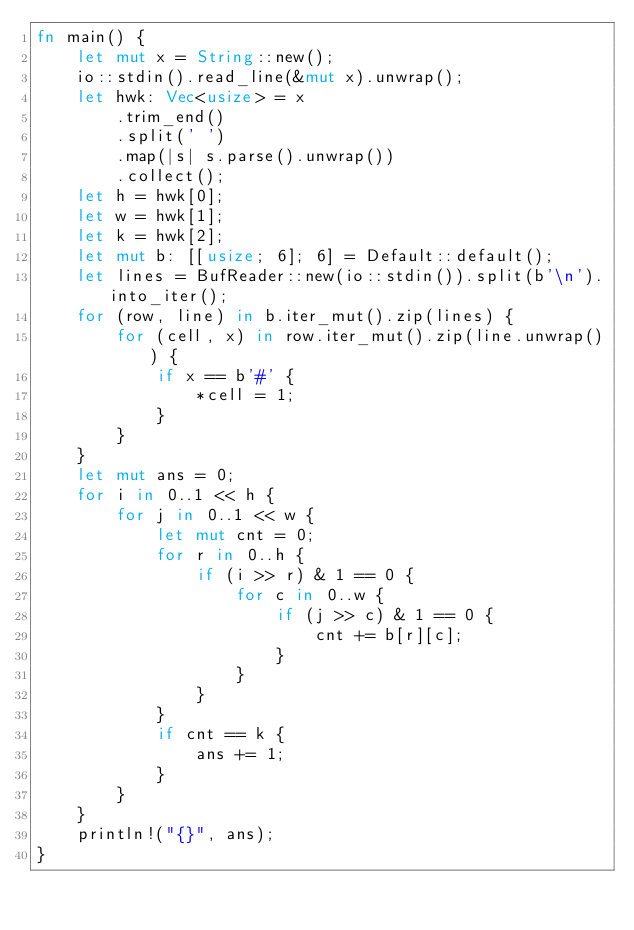<code> <loc_0><loc_0><loc_500><loc_500><_Rust_>fn main() {
    let mut x = String::new();
    io::stdin().read_line(&mut x).unwrap();
    let hwk: Vec<usize> = x
        .trim_end()
        .split(' ')
        .map(|s| s.parse().unwrap())
        .collect();
    let h = hwk[0];
    let w = hwk[1];
    let k = hwk[2];
    let mut b: [[usize; 6]; 6] = Default::default();
    let lines = BufReader::new(io::stdin()).split(b'\n').into_iter();
    for (row, line) in b.iter_mut().zip(lines) {
        for (cell, x) in row.iter_mut().zip(line.unwrap()) {
            if x == b'#' {
                *cell = 1;
            }
        }
    }
    let mut ans = 0;
    for i in 0..1 << h {
        for j in 0..1 << w {
            let mut cnt = 0;
            for r in 0..h {
                if (i >> r) & 1 == 0 {
                    for c in 0..w {
                        if (j >> c) & 1 == 0 {
                            cnt += b[r][c];
                        }
                    }
                }
            }
            if cnt == k {
                ans += 1;
            }
        }
    }
    println!("{}", ans);
}</code> 